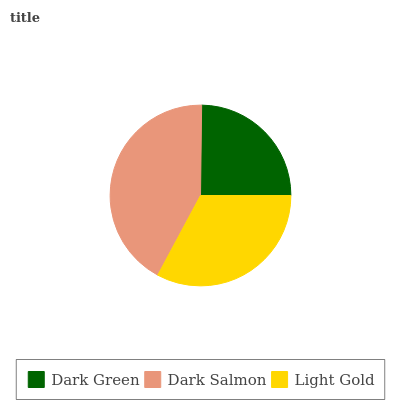Is Dark Green the minimum?
Answer yes or no. Yes. Is Dark Salmon the maximum?
Answer yes or no. Yes. Is Light Gold the minimum?
Answer yes or no. No. Is Light Gold the maximum?
Answer yes or no. No. Is Dark Salmon greater than Light Gold?
Answer yes or no. Yes. Is Light Gold less than Dark Salmon?
Answer yes or no. Yes. Is Light Gold greater than Dark Salmon?
Answer yes or no. No. Is Dark Salmon less than Light Gold?
Answer yes or no. No. Is Light Gold the high median?
Answer yes or no. Yes. Is Light Gold the low median?
Answer yes or no. Yes. Is Dark Green the high median?
Answer yes or no. No. Is Dark Salmon the low median?
Answer yes or no. No. 